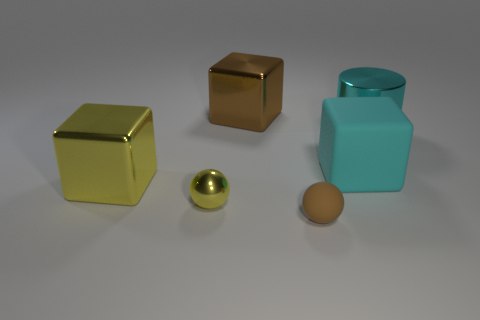Add 2 small brown things. How many objects exist? 8 Subtract all cylinders. How many objects are left? 5 Add 6 large brown blocks. How many large brown blocks are left? 7 Add 1 tiny red metal cylinders. How many tiny red metal cylinders exist? 1 Subtract 0 blue blocks. How many objects are left? 6 Subtract all large matte blocks. Subtract all small matte things. How many objects are left? 4 